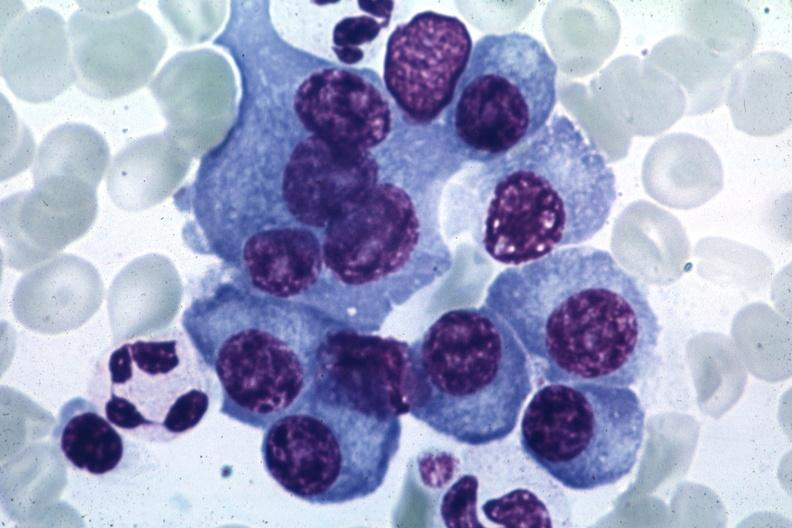does this image show typical cells with some pleomorphism suspicious for multiple myeloma source unknown?
Answer the question using a single word or phrase. Yes 